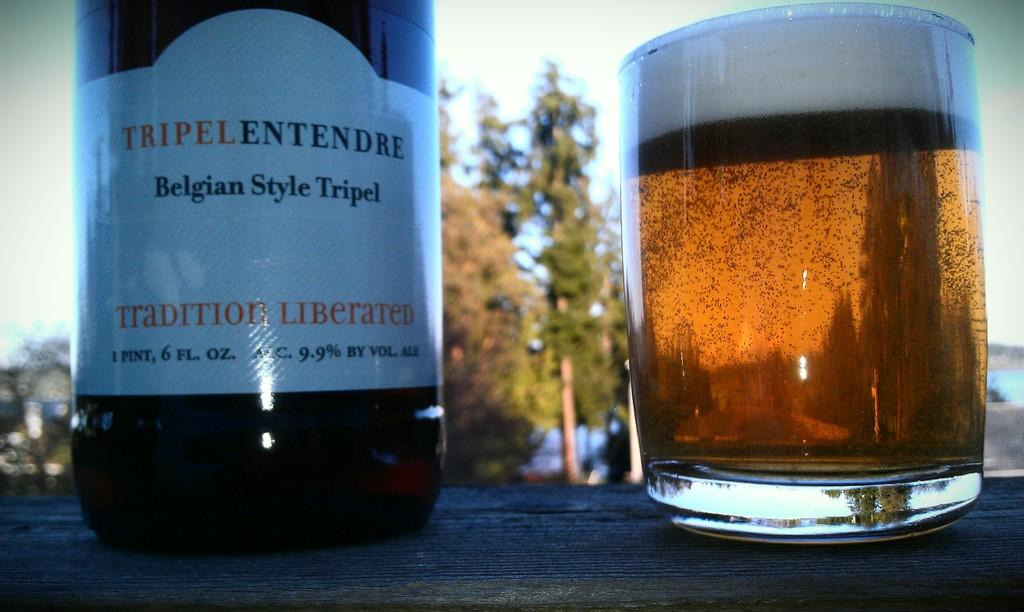Provide a one-sentence caption for the provided image. A bottle of Belgian Style Tripel sits next to a glass of amber liquid. 